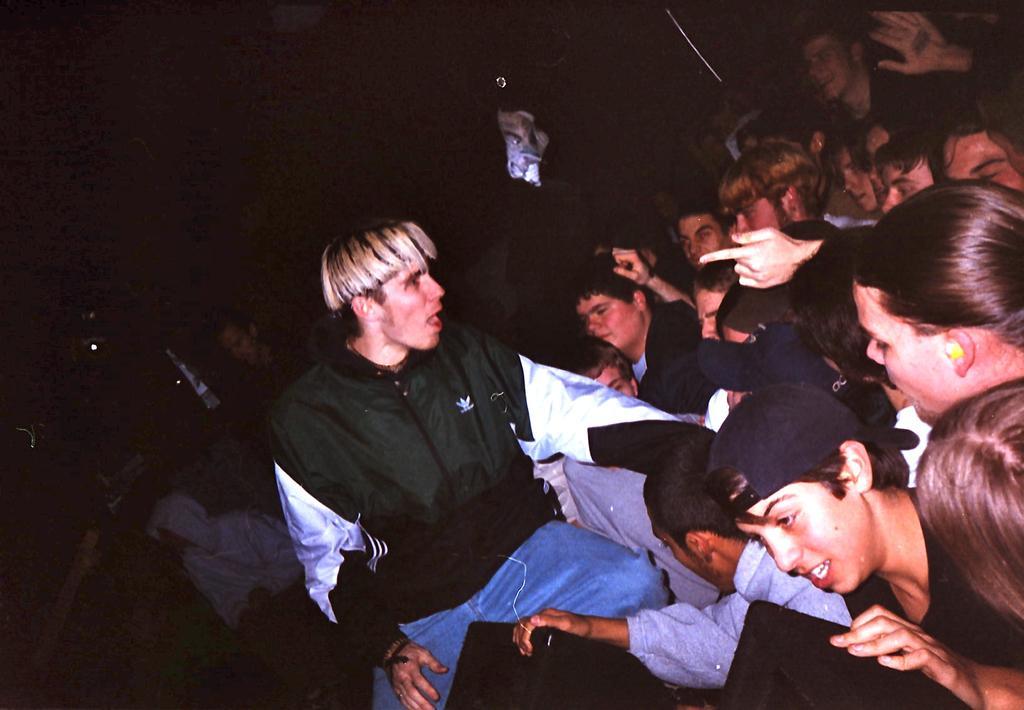How would you summarize this image in a sentence or two? In this image we can see group of persons standing. One person is wearing a cap. In the foreground of the image we can see the speakers. 